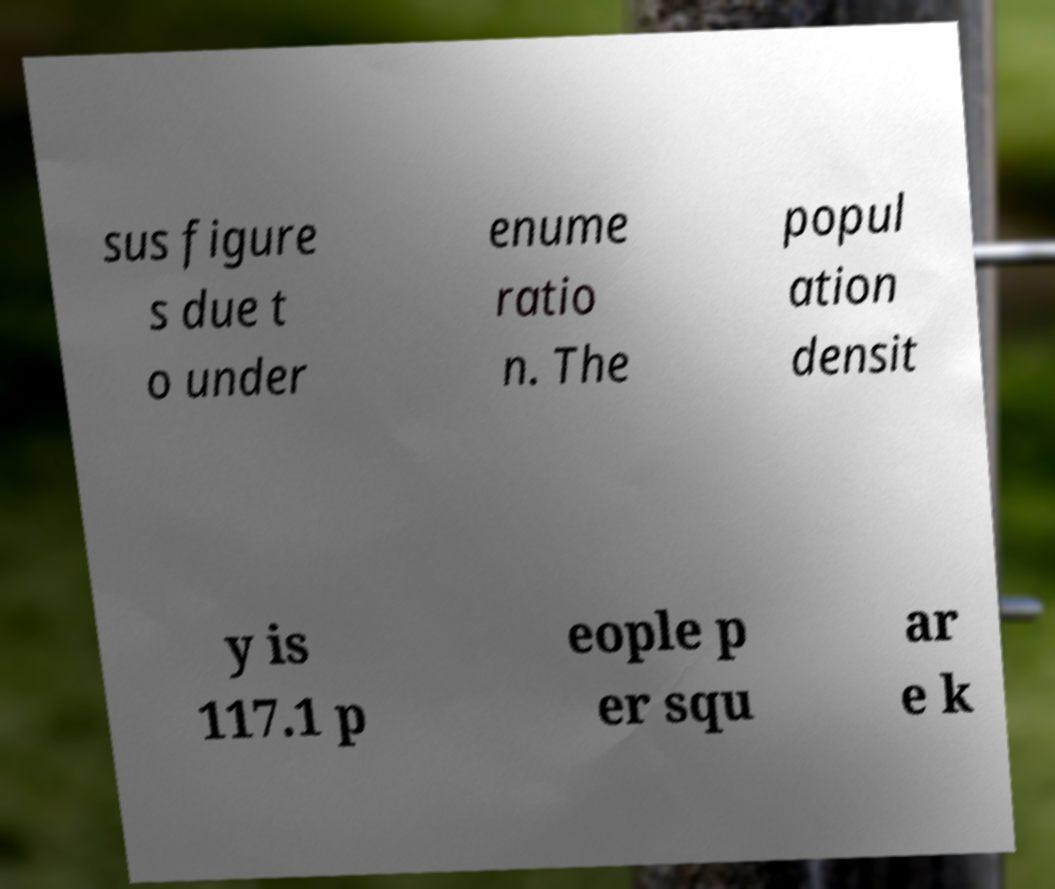Can you read and provide the text displayed in the image?This photo seems to have some interesting text. Can you extract and type it out for me? sus figure s due t o under enume ratio n. The popul ation densit y is 117.1 p eople p er squ ar e k 